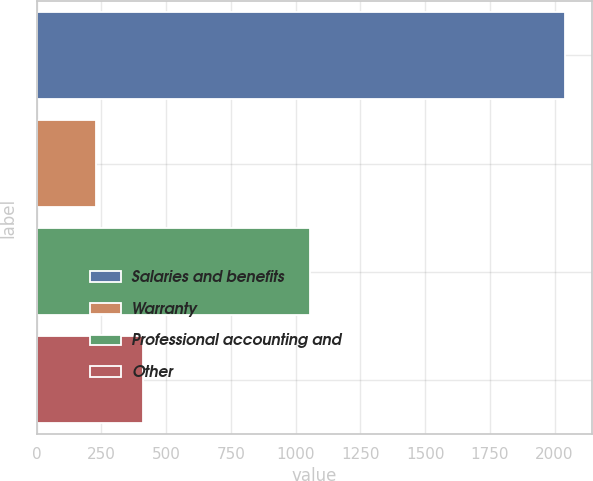Convert chart to OTSL. <chart><loc_0><loc_0><loc_500><loc_500><bar_chart><fcel>Salaries and benefits<fcel>Warranty<fcel>Professional accounting and<fcel>Other<nl><fcel>2041<fcel>231<fcel>1057<fcel>412<nl></chart> 